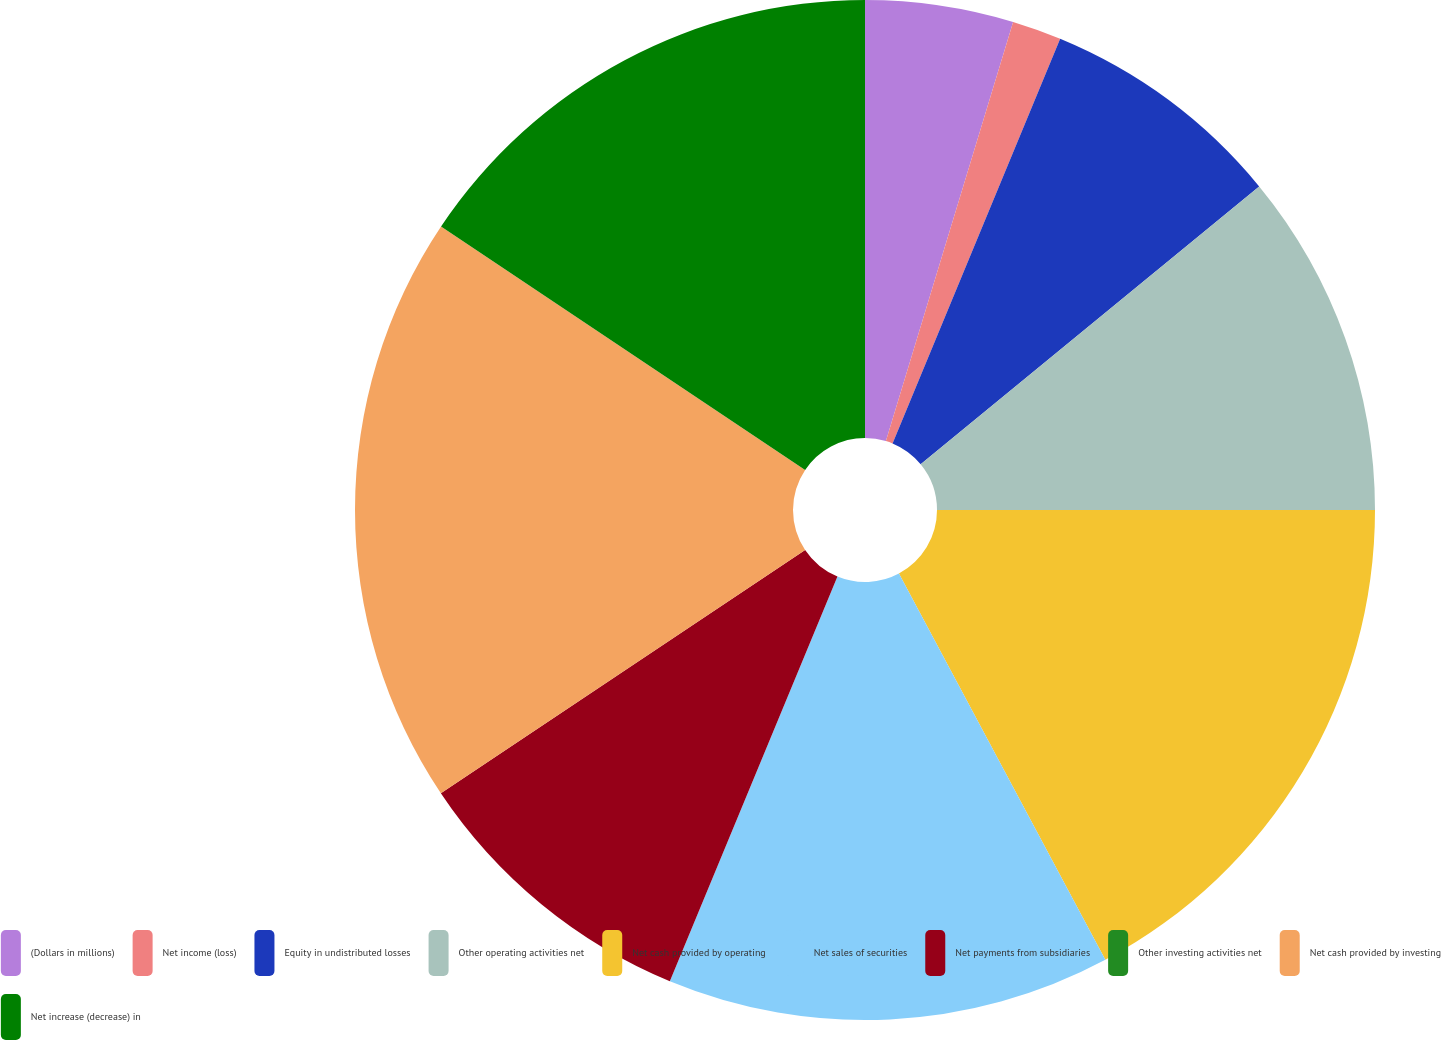Convert chart to OTSL. <chart><loc_0><loc_0><loc_500><loc_500><pie_chart><fcel>(Dollars in millions)<fcel>Net income (loss)<fcel>Equity in undistributed losses<fcel>Other operating activities net<fcel>Net cash provided by operating<fcel>Net sales of securities<fcel>Net payments from subsidiaries<fcel>Other investing activities net<fcel>Net cash provided by investing<fcel>Net increase (decrease) in<nl><fcel>4.69%<fcel>1.56%<fcel>7.81%<fcel>10.94%<fcel>17.19%<fcel>14.06%<fcel>9.38%<fcel>0.0%<fcel>18.75%<fcel>15.62%<nl></chart> 